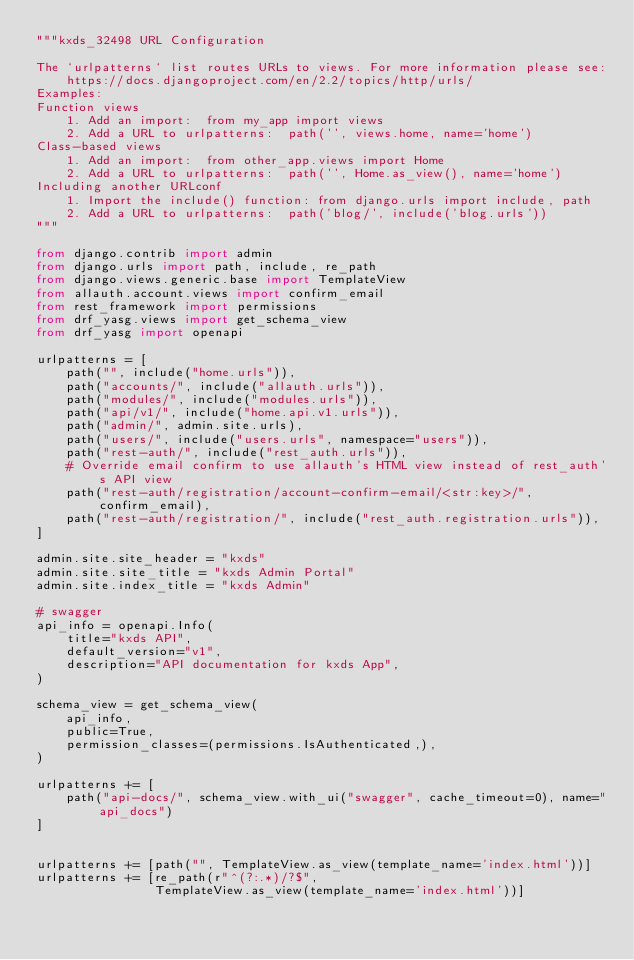Convert code to text. <code><loc_0><loc_0><loc_500><loc_500><_Python_>"""kxds_32498 URL Configuration

The `urlpatterns` list routes URLs to views. For more information please see:
    https://docs.djangoproject.com/en/2.2/topics/http/urls/
Examples:
Function views
    1. Add an import:  from my_app import views
    2. Add a URL to urlpatterns:  path('', views.home, name='home')
Class-based views
    1. Add an import:  from other_app.views import Home
    2. Add a URL to urlpatterns:  path('', Home.as_view(), name='home')
Including another URLconf
    1. Import the include() function: from django.urls import include, path
    2. Add a URL to urlpatterns:  path('blog/', include('blog.urls'))
"""

from django.contrib import admin
from django.urls import path, include, re_path
from django.views.generic.base import TemplateView
from allauth.account.views import confirm_email
from rest_framework import permissions
from drf_yasg.views import get_schema_view
from drf_yasg import openapi

urlpatterns = [
    path("", include("home.urls")),
    path("accounts/", include("allauth.urls")),
    path("modules/", include("modules.urls")),
    path("api/v1/", include("home.api.v1.urls")),
    path("admin/", admin.site.urls),
    path("users/", include("users.urls", namespace="users")),
    path("rest-auth/", include("rest_auth.urls")),
    # Override email confirm to use allauth's HTML view instead of rest_auth's API view
    path("rest-auth/registration/account-confirm-email/<str:key>/", confirm_email),
    path("rest-auth/registration/", include("rest_auth.registration.urls")),
]

admin.site.site_header = "kxds"
admin.site.site_title = "kxds Admin Portal"
admin.site.index_title = "kxds Admin"

# swagger
api_info = openapi.Info(
    title="kxds API",
    default_version="v1",
    description="API documentation for kxds App",
)

schema_view = get_schema_view(
    api_info,
    public=True,
    permission_classes=(permissions.IsAuthenticated,),
)

urlpatterns += [
    path("api-docs/", schema_view.with_ui("swagger", cache_timeout=0), name="api_docs")
]


urlpatterns += [path("", TemplateView.as_view(template_name='index.html'))]
urlpatterns += [re_path(r"^(?:.*)/?$",
                TemplateView.as_view(template_name='index.html'))]
</code> 